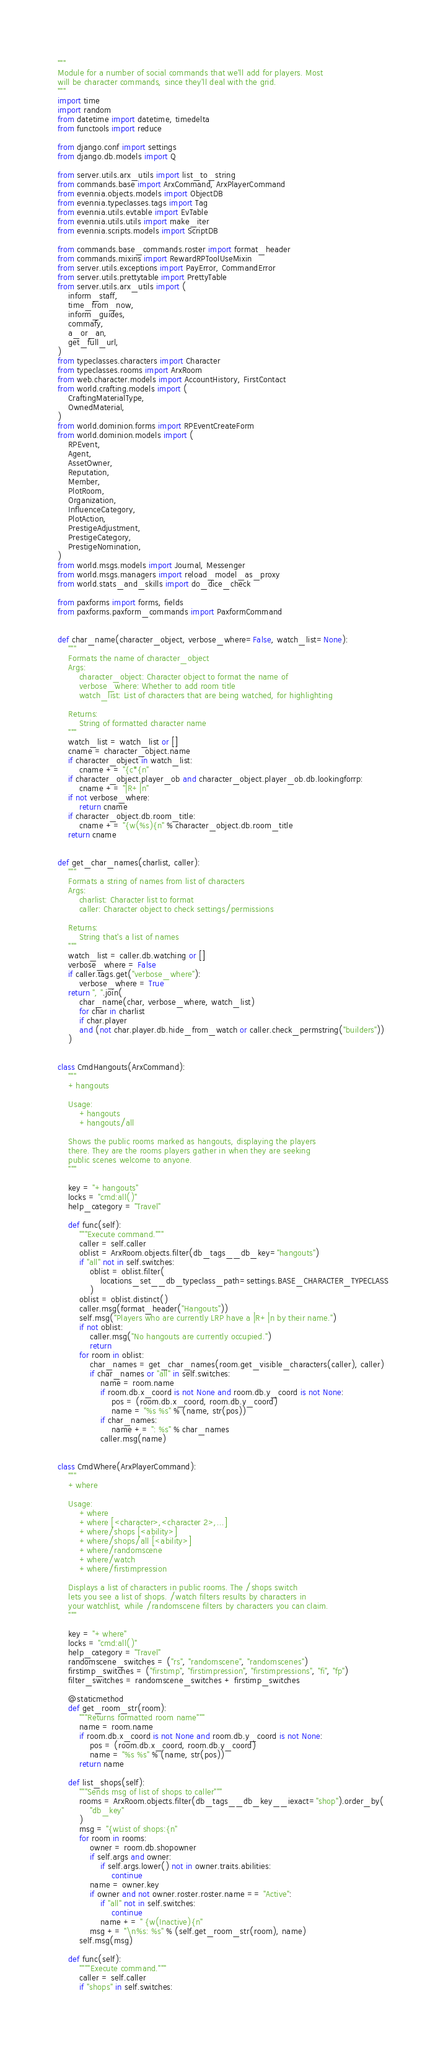<code> <loc_0><loc_0><loc_500><loc_500><_Python_>"""
Module for a number of social commands that we'll add for players. Most
will be character commands, since they'll deal with the grid.
"""
import time
import random
from datetime import datetime, timedelta
from functools import reduce

from django.conf import settings
from django.db.models import Q

from server.utils.arx_utils import list_to_string
from commands.base import ArxCommand, ArxPlayerCommand
from evennia.objects.models import ObjectDB
from evennia.typeclasses.tags import Tag
from evennia.utils.evtable import EvTable
from evennia.utils.utils import make_iter
from evennia.scripts.models import ScriptDB

from commands.base_commands.roster import format_header
from commands.mixins import RewardRPToolUseMixin
from server.utils.exceptions import PayError, CommandError
from server.utils.prettytable import PrettyTable
from server.utils.arx_utils import (
    inform_staff,
    time_from_now,
    inform_guides,
    commafy,
    a_or_an,
    get_full_url,
)
from typeclasses.characters import Character
from typeclasses.rooms import ArxRoom
from web.character.models import AccountHistory, FirstContact
from world.crafting.models import (
    CraftingMaterialType,
    OwnedMaterial,
)
from world.dominion.forms import RPEventCreateForm
from world.dominion.models import (
    RPEvent,
    Agent,
    AssetOwner,
    Reputation,
    Member,
    PlotRoom,
    Organization,
    InfluenceCategory,
    PlotAction,
    PrestigeAdjustment,
    PrestigeCategory,
    PrestigeNomination,
)
from world.msgs.models import Journal, Messenger
from world.msgs.managers import reload_model_as_proxy
from world.stats_and_skills import do_dice_check

from paxforms import forms, fields
from paxforms.paxform_commands import PaxformCommand


def char_name(character_object, verbose_where=False, watch_list=None):
    """
    Formats the name of character_object
    Args:
        character_object: Character object to format the name of
        verbose_where: Whether to add room title
        watch_list: List of characters that are being watched, for highlighting

    Returns:
        String of formatted character name
    """
    watch_list = watch_list or []
    cname = character_object.name
    if character_object in watch_list:
        cname += "{c*{n"
    if character_object.player_ob and character_object.player_ob.db.lookingforrp:
        cname += "|R+|n"
    if not verbose_where:
        return cname
    if character_object.db.room_title:
        cname += "{w(%s){n" % character_object.db.room_title
    return cname


def get_char_names(charlist, caller):
    """
    Formats a string of names from list of characters
    Args:
        charlist: Character list to format
        caller: Character object to check settings/permissions

    Returns:
        String that's a list of names
    """
    watch_list = caller.db.watching or []
    verbose_where = False
    if caller.tags.get("verbose_where"):
        verbose_where = True
    return ", ".join(
        char_name(char, verbose_where, watch_list)
        for char in charlist
        if char.player
        and (not char.player.db.hide_from_watch or caller.check_permstring("builders"))
    )


class CmdHangouts(ArxCommand):
    """
    +hangouts

    Usage:
        +hangouts
        +hangouts/all

    Shows the public rooms marked as hangouts, displaying the players
    there. They are the rooms players gather in when they are seeking
    public scenes welcome to anyone.
    """

    key = "+hangouts"
    locks = "cmd:all()"
    help_category = "Travel"

    def func(self):
        """Execute command."""
        caller = self.caller
        oblist = ArxRoom.objects.filter(db_tags__db_key="hangouts")
        if "all" not in self.switches:
            oblist = oblist.filter(
                locations_set__db_typeclass_path=settings.BASE_CHARACTER_TYPECLASS
            )
        oblist = oblist.distinct()
        caller.msg(format_header("Hangouts"))
        self.msg("Players who are currently LRP have a |R+|n by their name.")
        if not oblist:
            caller.msg("No hangouts are currently occupied.")
            return
        for room in oblist:
            char_names = get_char_names(room.get_visible_characters(caller), caller)
            if char_names or "all" in self.switches:
                name = room.name
                if room.db.x_coord is not None and room.db.y_coord is not None:
                    pos = (room.db.x_coord, room.db.y_coord)
                    name = "%s %s" % (name, str(pos))
                if char_names:
                    name += ": %s" % char_names
                caller.msg(name)


class CmdWhere(ArxPlayerCommand):
    """
    +where

    Usage:
        +where
        +where [<character>,<character 2>,...]
        +where/shops [<ability>]
        +where/shops/all [<ability>]
        +where/randomscene
        +where/watch
        +where/firstimpression

    Displays a list of characters in public rooms. The /shops switch
    lets you see a list of shops. /watch filters results by characters in
    your watchlist, while /randomscene filters by characters you can claim.
    """

    key = "+where"
    locks = "cmd:all()"
    help_category = "Travel"
    randomscene_switches = ("rs", "randomscene", "randomscenes")
    firstimp_switches = ("firstimp", "firstimpression", "firstimpressions", "fi", "fp")
    filter_switches = randomscene_switches + firstimp_switches

    @staticmethod
    def get_room_str(room):
        """Returns formatted room name"""
        name = room.name
        if room.db.x_coord is not None and room.db.y_coord is not None:
            pos = (room.db.x_coord, room.db.y_coord)
            name = "%s %s" % (name, str(pos))
        return name

    def list_shops(self):
        """Sends msg of list of shops to caller"""
        rooms = ArxRoom.objects.filter(db_tags__db_key__iexact="shop").order_by(
            "db_key"
        )
        msg = "{wList of shops:{n"
        for room in rooms:
            owner = room.db.shopowner
            if self.args and owner:
                if self.args.lower() not in owner.traits.abilities:
                    continue
            name = owner.key
            if owner and not owner.roster.roster.name == "Active":
                if "all" not in self.switches:
                    continue
                name += " {w(Inactive){n"
            msg += "\n%s: %s" % (self.get_room_str(room), name)
        self.msg(msg)

    def func(self):
        """"Execute command."""
        caller = self.caller
        if "shops" in self.switches:</code> 